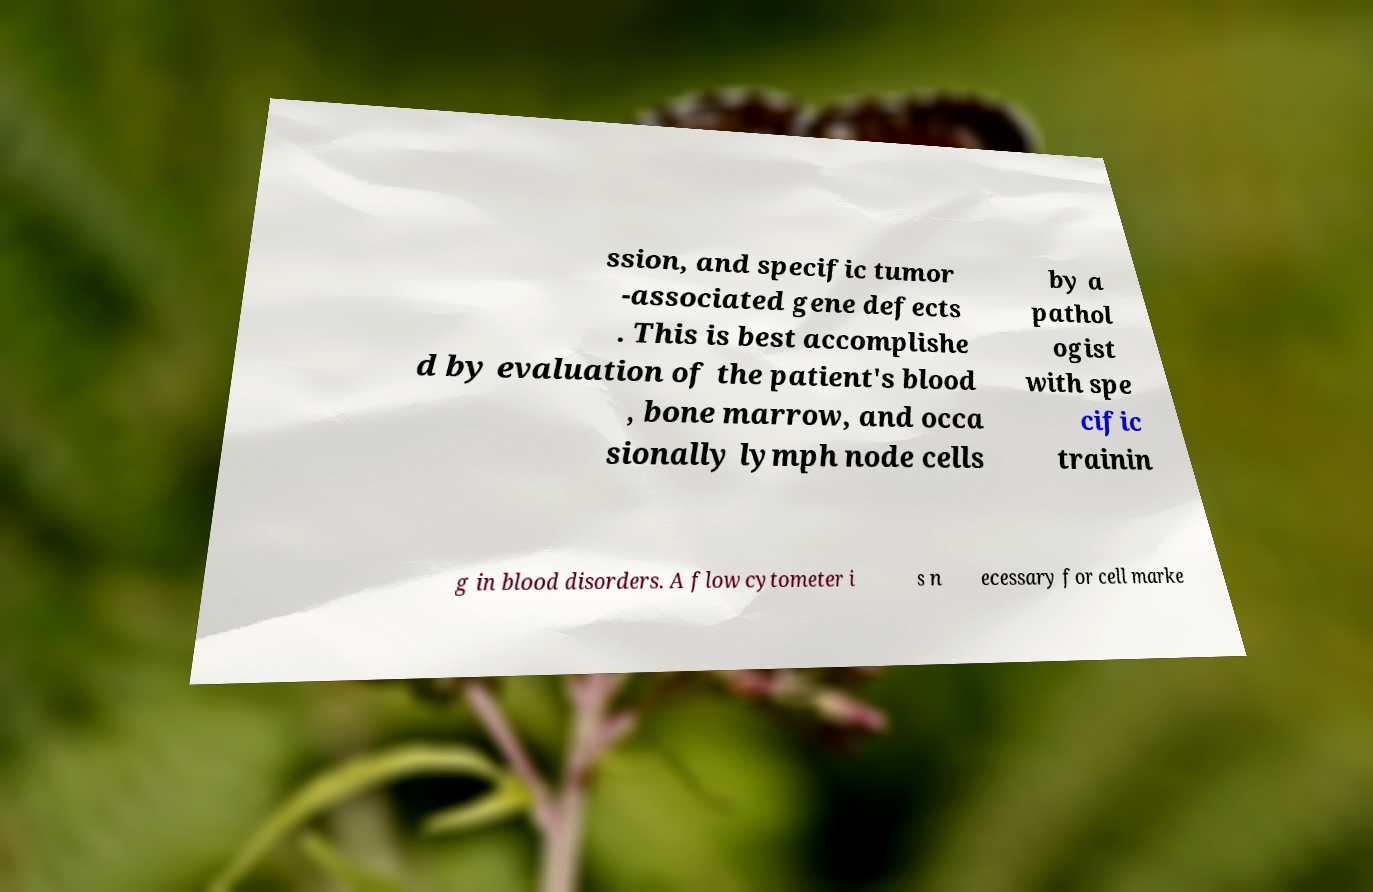Please identify and transcribe the text found in this image. ssion, and specific tumor -associated gene defects . This is best accomplishe d by evaluation of the patient's blood , bone marrow, and occa sionally lymph node cells by a pathol ogist with spe cific trainin g in blood disorders. A flow cytometer i s n ecessary for cell marke 